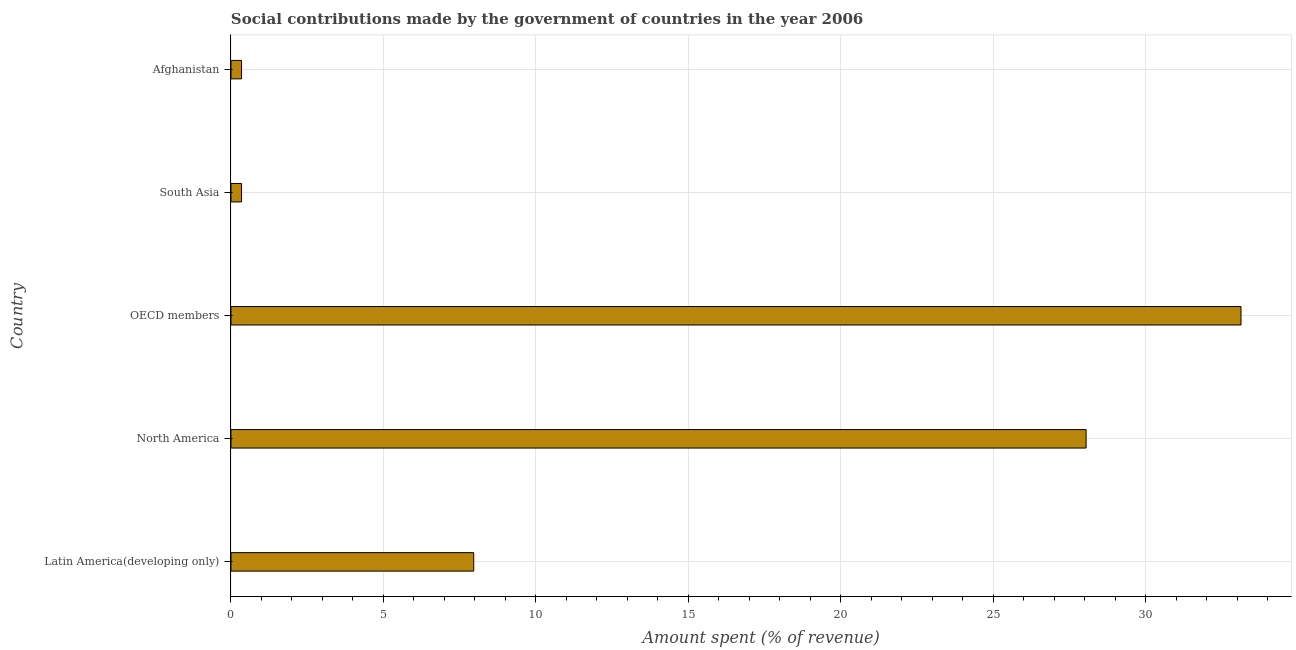What is the title of the graph?
Provide a short and direct response. Social contributions made by the government of countries in the year 2006. What is the label or title of the X-axis?
Keep it short and to the point. Amount spent (% of revenue). What is the label or title of the Y-axis?
Provide a succinct answer. Country. What is the amount spent in making social contributions in North America?
Your response must be concise. 28.05. Across all countries, what is the maximum amount spent in making social contributions?
Offer a terse response. 33.13. Across all countries, what is the minimum amount spent in making social contributions?
Keep it short and to the point. 0.35. What is the sum of the amount spent in making social contributions?
Offer a very short reply. 69.83. What is the difference between the amount spent in making social contributions in Latin America(developing only) and OECD members?
Ensure brevity in your answer.  -25.16. What is the average amount spent in making social contributions per country?
Provide a succinct answer. 13.96. What is the median amount spent in making social contributions?
Offer a very short reply. 7.96. What is the ratio of the amount spent in making social contributions in North America to that in South Asia?
Ensure brevity in your answer.  81.13. Is the amount spent in making social contributions in North America less than that in OECD members?
Give a very brief answer. Yes. What is the difference between the highest and the second highest amount spent in making social contributions?
Keep it short and to the point. 5.08. What is the difference between the highest and the lowest amount spent in making social contributions?
Provide a succinct answer. 32.78. Are all the bars in the graph horizontal?
Your answer should be compact. Yes. How many countries are there in the graph?
Your response must be concise. 5. Are the values on the major ticks of X-axis written in scientific E-notation?
Your response must be concise. No. What is the Amount spent (% of revenue) of Latin America(developing only)?
Offer a terse response. 7.96. What is the Amount spent (% of revenue) of North America?
Make the answer very short. 28.05. What is the Amount spent (% of revenue) in OECD members?
Provide a succinct answer. 33.13. What is the Amount spent (% of revenue) in South Asia?
Ensure brevity in your answer.  0.35. What is the Amount spent (% of revenue) in Afghanistan?
Provide a short and direct response. 0.35. What is the difference between the Amount spent (% of revenue) in Latin America(developing only) and North America?
Keep it short and to the point. -20.09. What is the difference between the Amount spent (% of revenue) in Latin America(developing only) and OECD members?
Ensure brevity in your answer.  -25.16. What is the difference between the Amount spent (% of revenue) in Latin America(developing only) and South Asia?
Your answer should be compact. 7.62. What is the difference between the Amount spent (% of revenue) in Latin America(developing only) and Afghanistan?
Offer a terse response. 7.62. What is the difference between the Amount spent (% of revenue) in North America and OECD members?
Ensure brevity in your answer.  -5.08. What is the difference between the Amount spent (% of revenue) in North America and South Asia?
Offer a terse response. 27.7. What is the difference between the Amount spent (% of revenue) in North America and Afghanistan?
Offer a very short reply. 27.7. What is the difference between the Amount spent (% of revenue) in OECD members and South Asia?
Give a very brief answer. 32.78. What is the difference between the Amount spent (% of revenue) in OECD members and Afghanistan?
Give a very brief answer. 32.78. What is the difference between the Amount spent (% of revenue) in South Asia and Afghanistan?
Your response must be concise. 0. What is the ratio of the Amount spent (% of revenue) in Latin America(developing only) to that in North America?
Give a very brief answer. 0.28. What is the ratio of the Amount spent (% of revenue) in Latin America(developing only) to that in OECD members?
Make the answer very short. 0.24. What is the ratio of the Amount spent (% of revenue) in Latin America(developing only) to that in South Asia?
Offer a very short reply. 23.03. What is the ratio of the Amount spent (% of revenue) in Latin America(developing only) to that in Afghanistan?
Make the answer very short. 23.03. What is the ratio of the Amount spent (% of revenue) in North America to that in OECD members?
Your answer should be very brief. 0.85. What is the ratio of the Amount spent (% of revenue) in North America to that in South Asia?
Your answer should be compact. 81.13. What is the ratio of the Amount spent (% of revenue) in North America to that in Afghanistan?
Your response must be concise. 81.13. What is the ratio of the Amount spent (% of revenue) in OECD members to that in South Asia?
Ensure brevity in your answer.  95.83. What is the ratio of the Amount spent (% of revenue) in OECD members to that in Afghanistan?
Provide a succinct answer. 95.83. What is the ratio of the Amount spent (% of revenue) in South Asia to that in Afghanistan?
Provide a short and direct response. 1. 